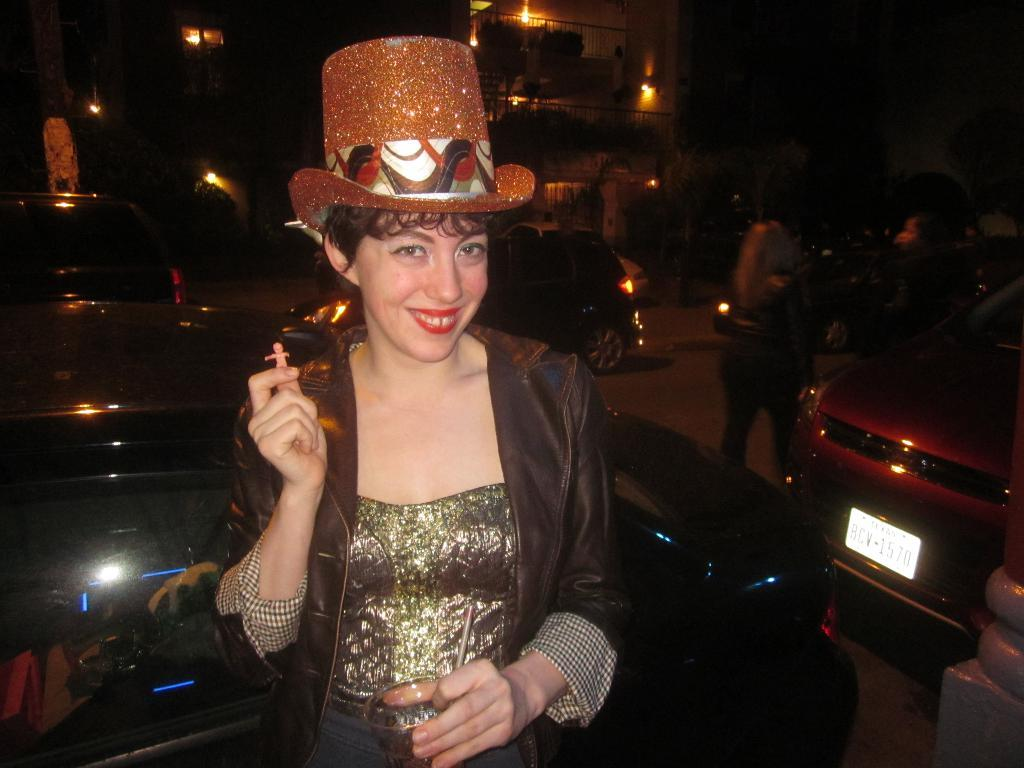What are the persons in the image doing? The persons in the image are standing and holding an object. What can be seen in the background of the image? There is a road, cars, a building, lights, and trees visible in the image. What book is the person reading in the image? There is no book present in the image. What is the title of the book the person is reading in the image? As mentioned earlier, there is no book present in the image, so it is not possible to determine the title. 